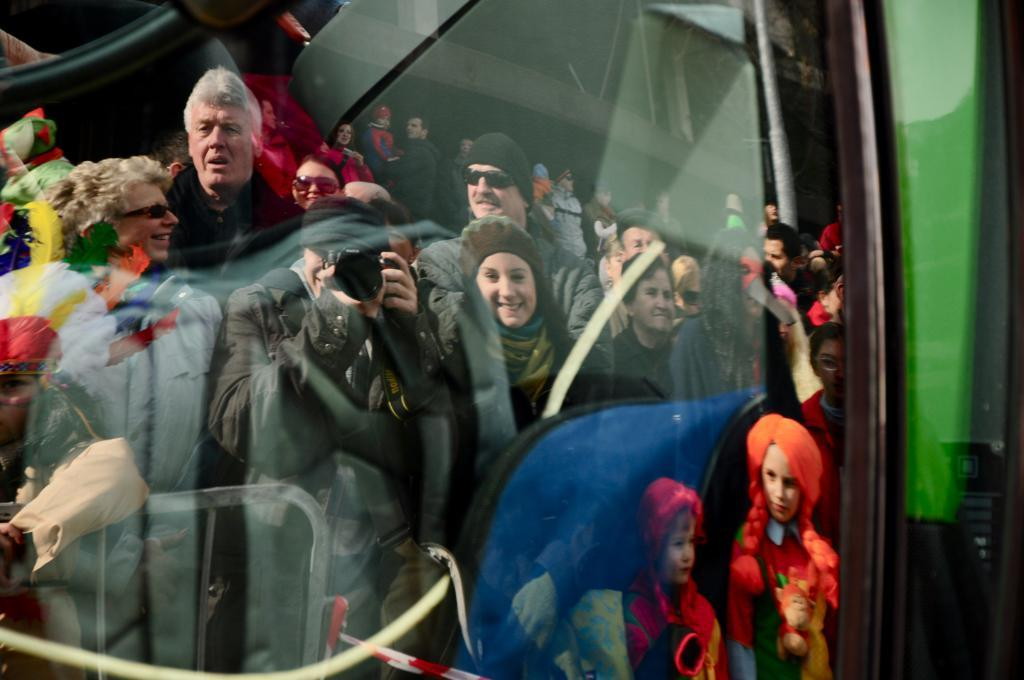What is happening in the image? There is a group of people standing in the image, and one person is holding a camera. Can you describe the person holding the camera? The person holding the camera is standing and holding the camera in their hands. Is there any reflection of the person holding the camera in the image? Yes, the person holding the camera is reflected in the image. How many babies are crawling on the floor in the image? There are no babies present in the image; it features a group of people and a person holding a camera. Can you tell me the color of the ladybug on the person's shoulder in the image? There is no ladybug present in the image; it only shows a group of people and a person holding a camera. 